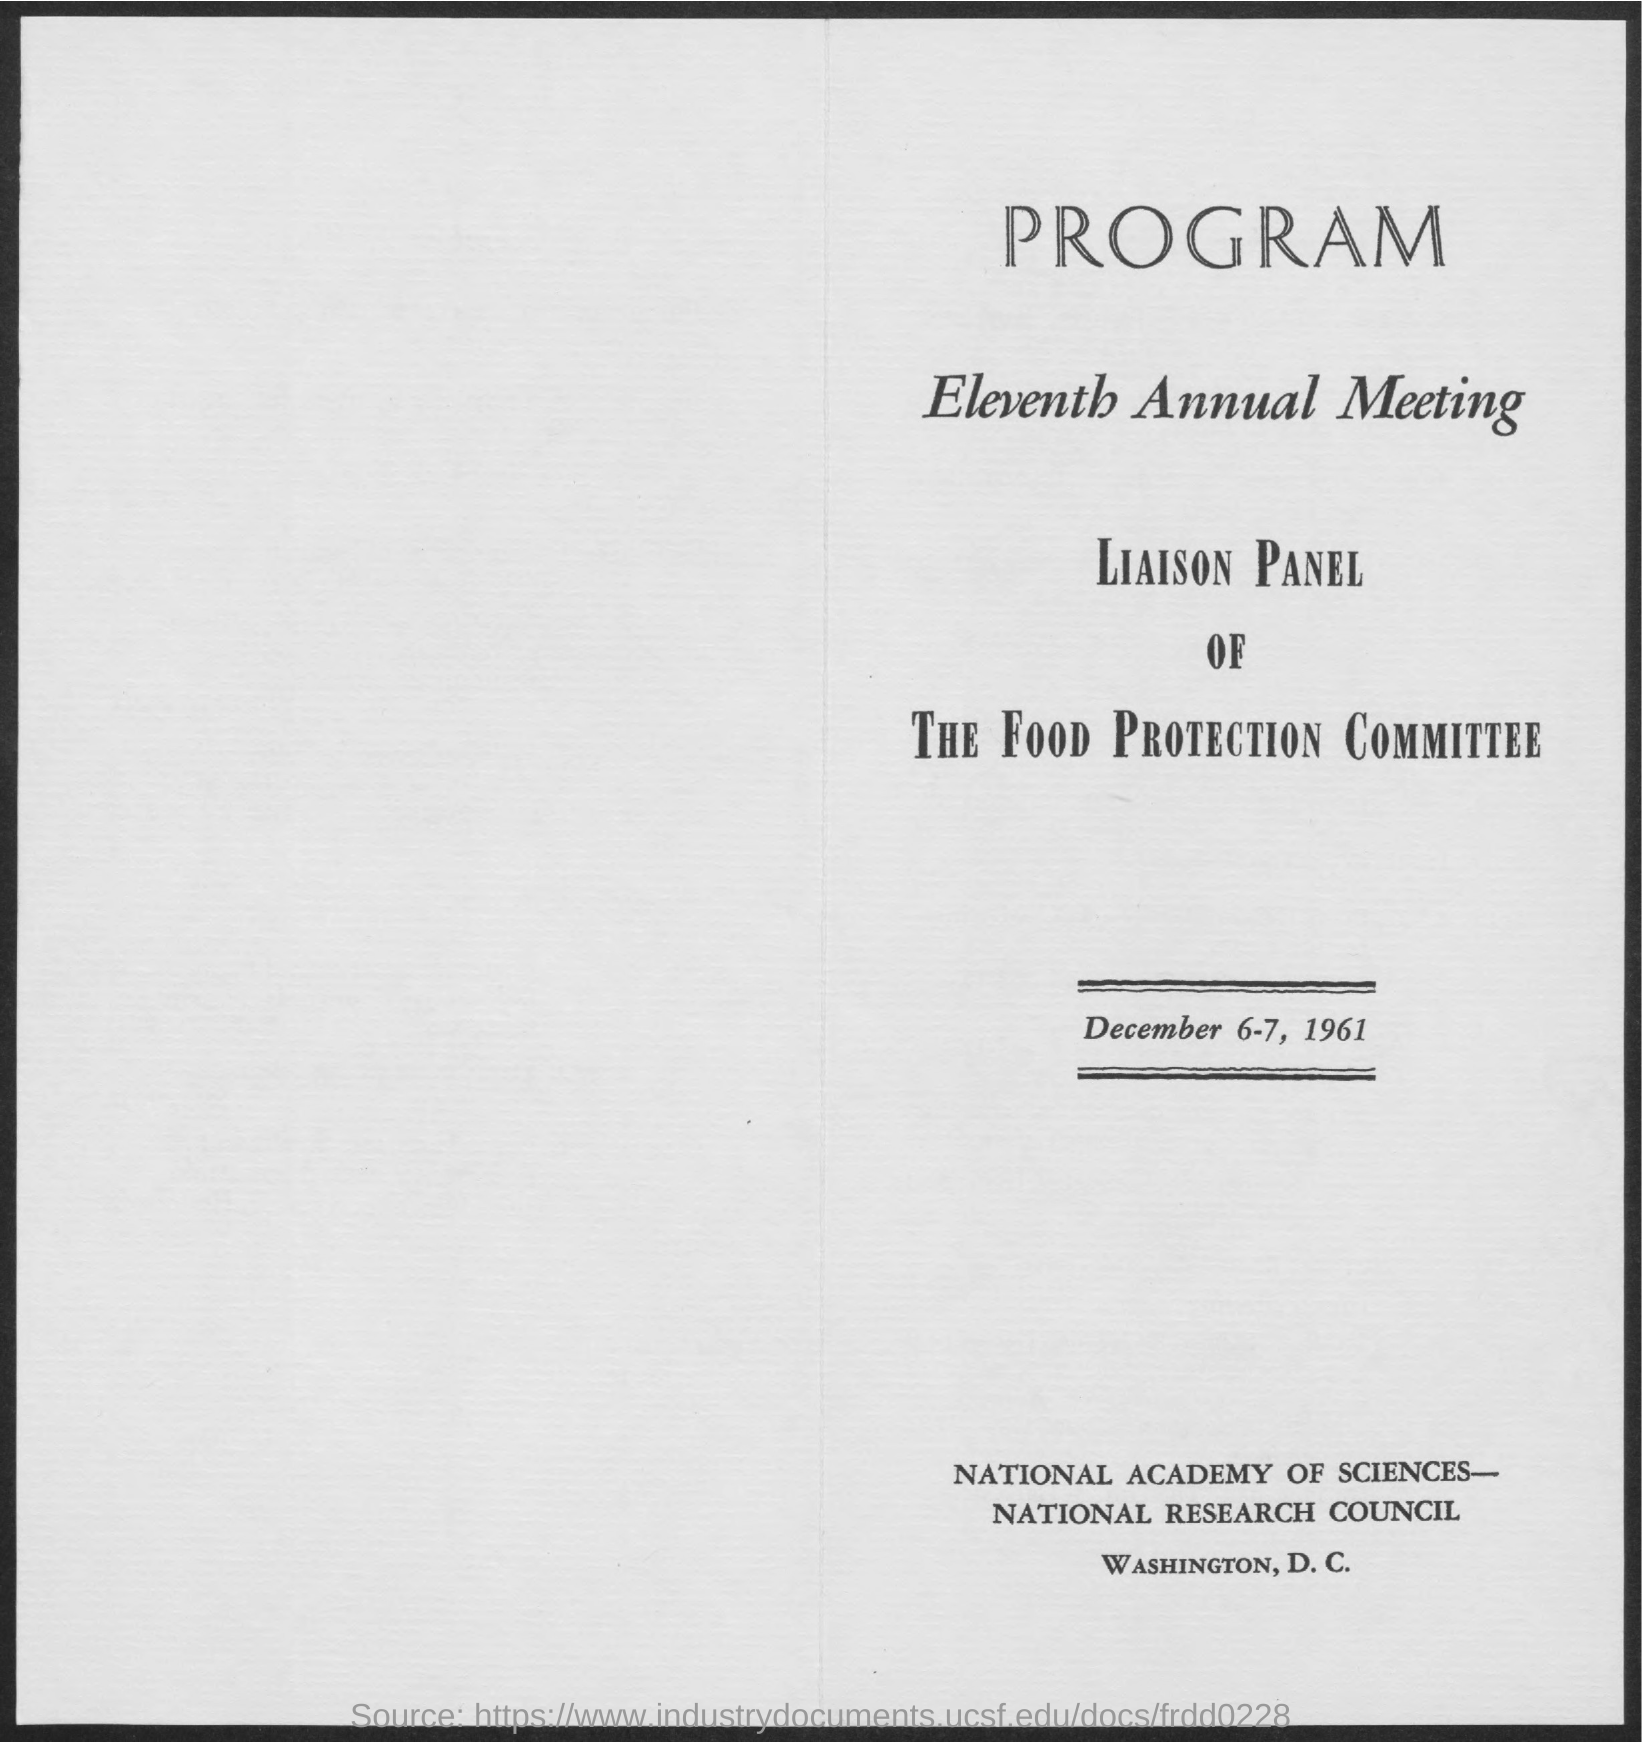When is the eleventh Annual Meeting?
Provide a succinct answer. December 6-7, 1961. 